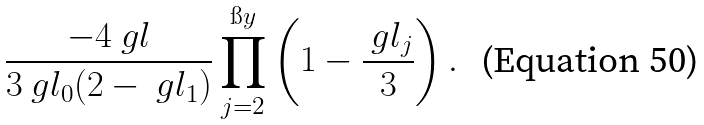Convert formula to latex. <formula><loc_0><loc_0><loc_500><loc_500>\frac { - 4 \ g l } { 3 \ g l _ { 0 } ( 2 - \ g l _ { 1 } ) } \prod _ { j = 2 } ^ { \i y } \left ( 1 - \frac { \ g l _ { j } } { 3 } \right ) .</formula> 